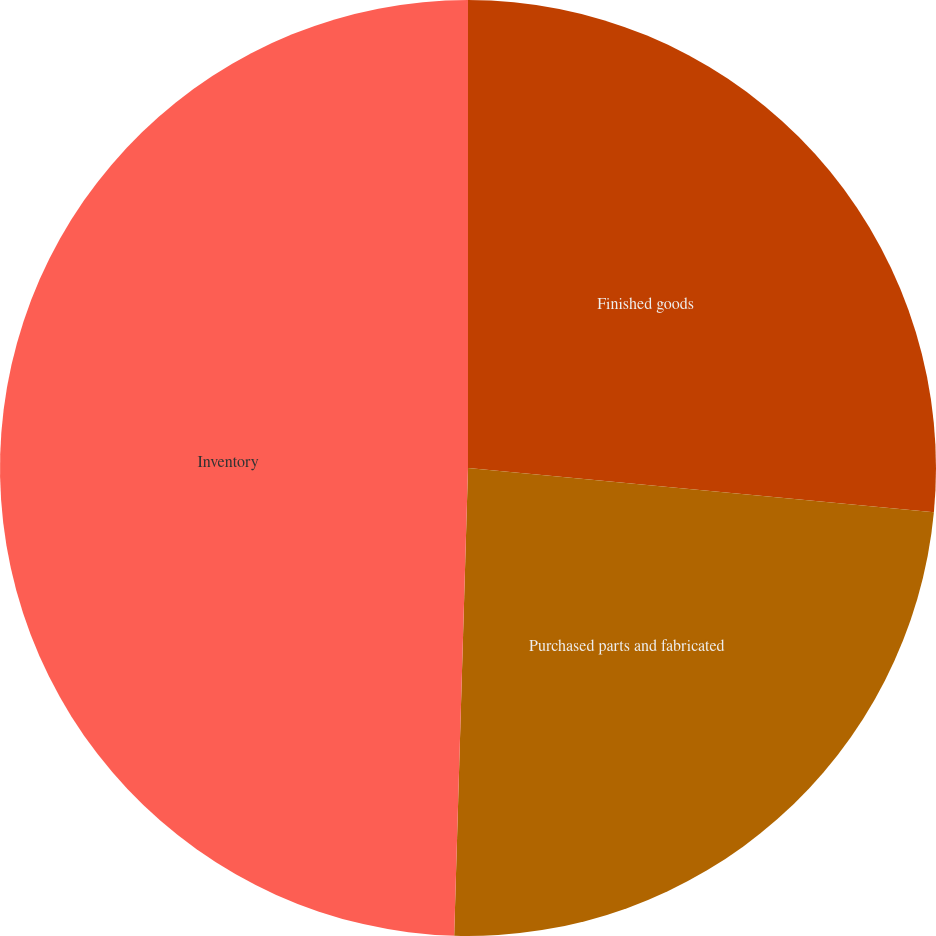Convert chart. <chart><loc_0><loc_0><loc_500><loc_500><pie_chart><fcel>Finished goods<fcel>Purchased parts and fabricated<fcel>Inventory<nl><fcel>26.51%<fcel>23.96%<fcel>49.53%<nl></chart> 